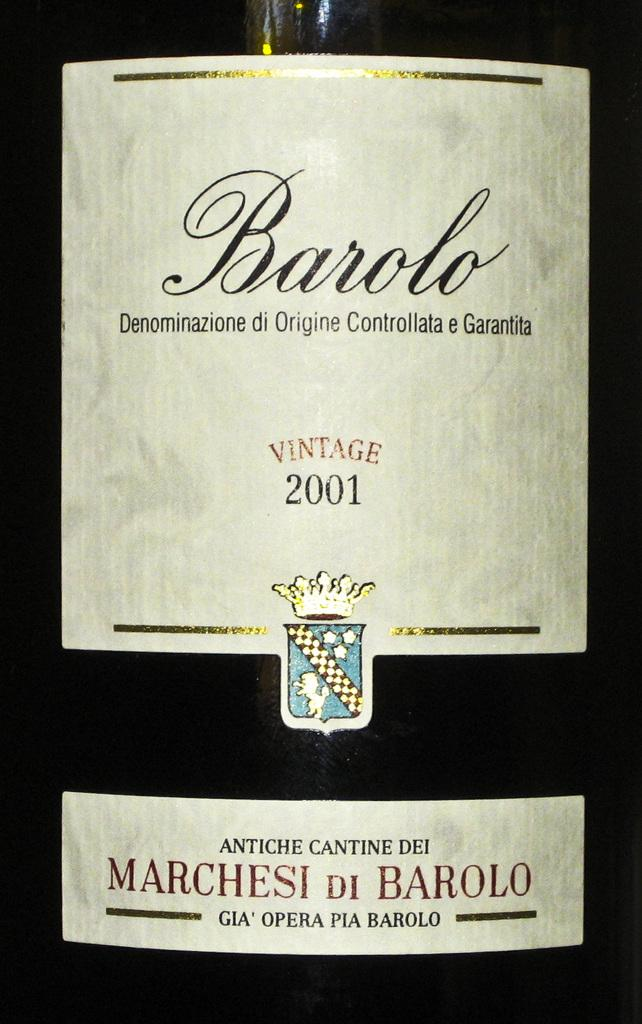<image>
Render a clear and concise summary of the photo. a vintage 2001 sign on the front of a wine bottle 